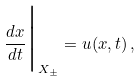Convert formula to latex. <formula><loc_0><loc_0><loc_500><loc_500>\frac { d x } { d t } \Big | _ { X _ { \pm } } = u ( x , t ) \, ,</formula> 